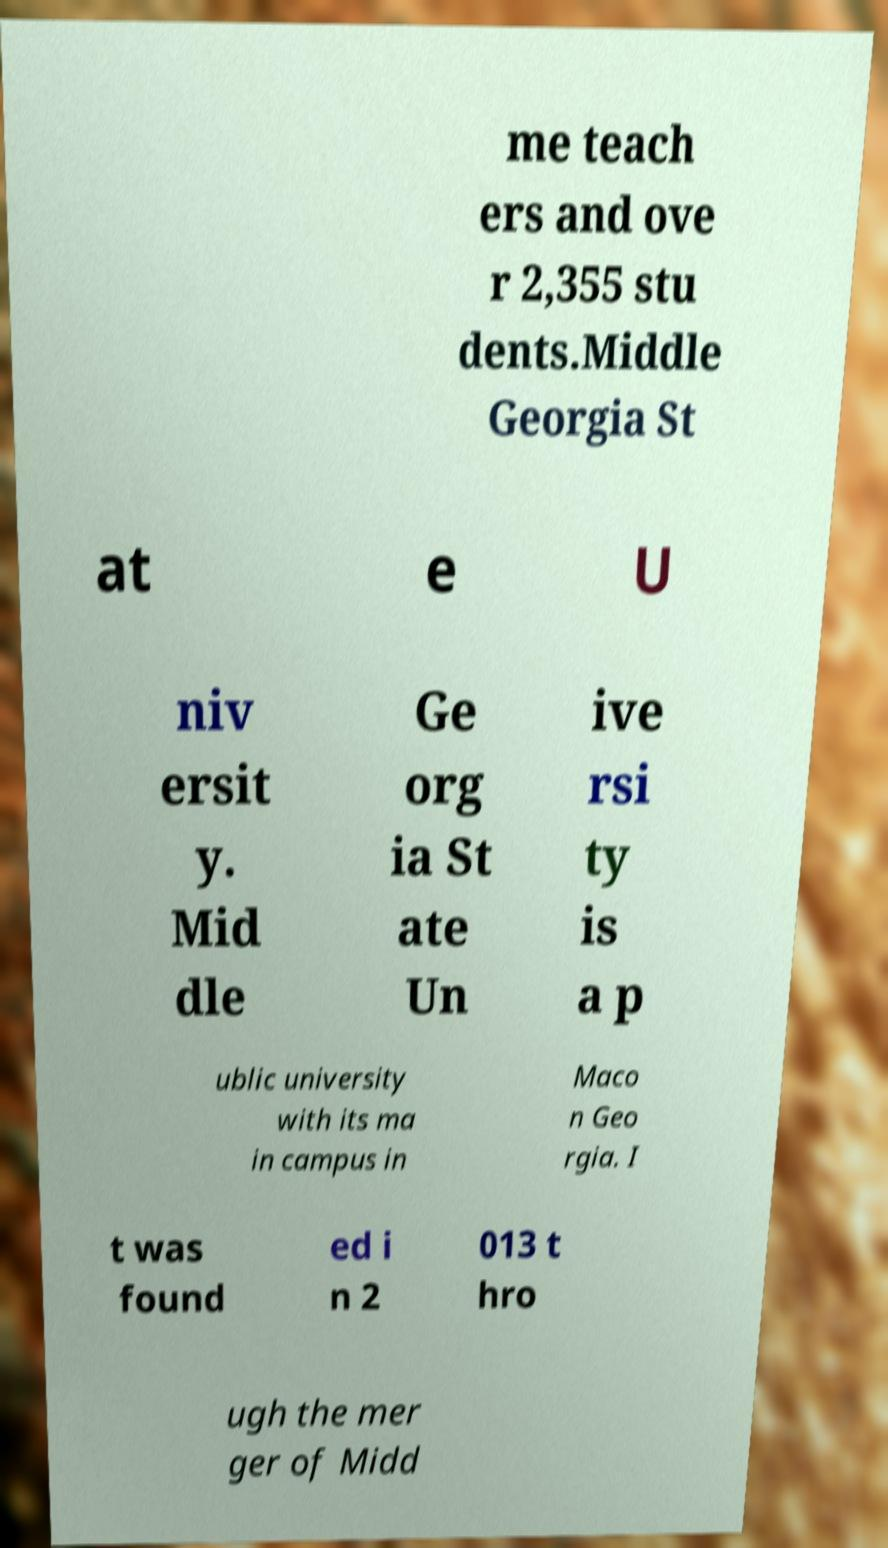I need the written content from this picture converted into text. Can you do that? me teach ers and ove r 2,355 stu dents.Middle Georgia St at e U niv ersit y. Mid dle Ge org ia St ate Un ive rsi ty is a p ublic university with its ma in campus in Maco n Geo rgia. I t was found ed i n 2 013 t hro ugh the mer ger of Midd 